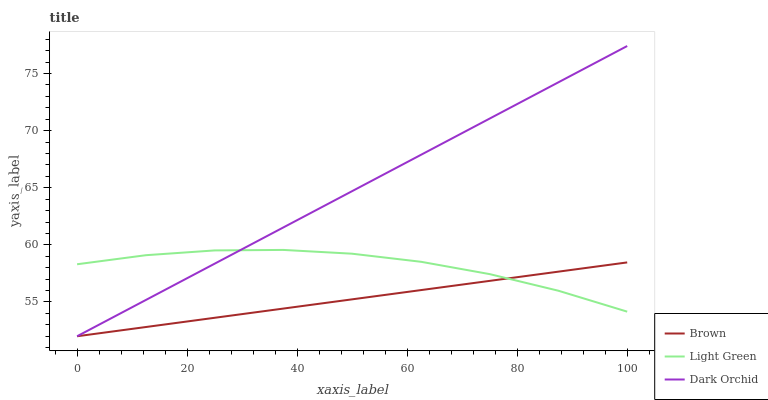Does Brown have the minimum area under the curve?
Answer yes or no. Yes. Does Dark Orchid have the maximum area under the curve?
Answer yes or no. Yes. Does Light Green have the minimum area under the curve?
Answer yes or no. No. Does Light Green have the maximum area under the curve?
Answer yes or no. No. Is Dark Orchid the smoothest?
Answer yes or no. Yes. Is Light Green the roughest?
Answer yes or no. Yes. Is Light Green the smoothest?
Answer yes or no. No. Is Dark Orchid the roughest?
Answer yes or no. No. Does Light Green have the lowest value?
Answer yes or no. No. Does Dark Orchid have the highest value?
Answer yes or no. Yes. Does Light Green have the highest value?
Answer yes or no. No. Does Dark Orchid intersect Brown?
Answer yes or no. Yes. Is Dark Orchid less than Brown?
Answer yes or no. No. Is Dark Orchid greater than Brown?
Answer yes or no. No. 